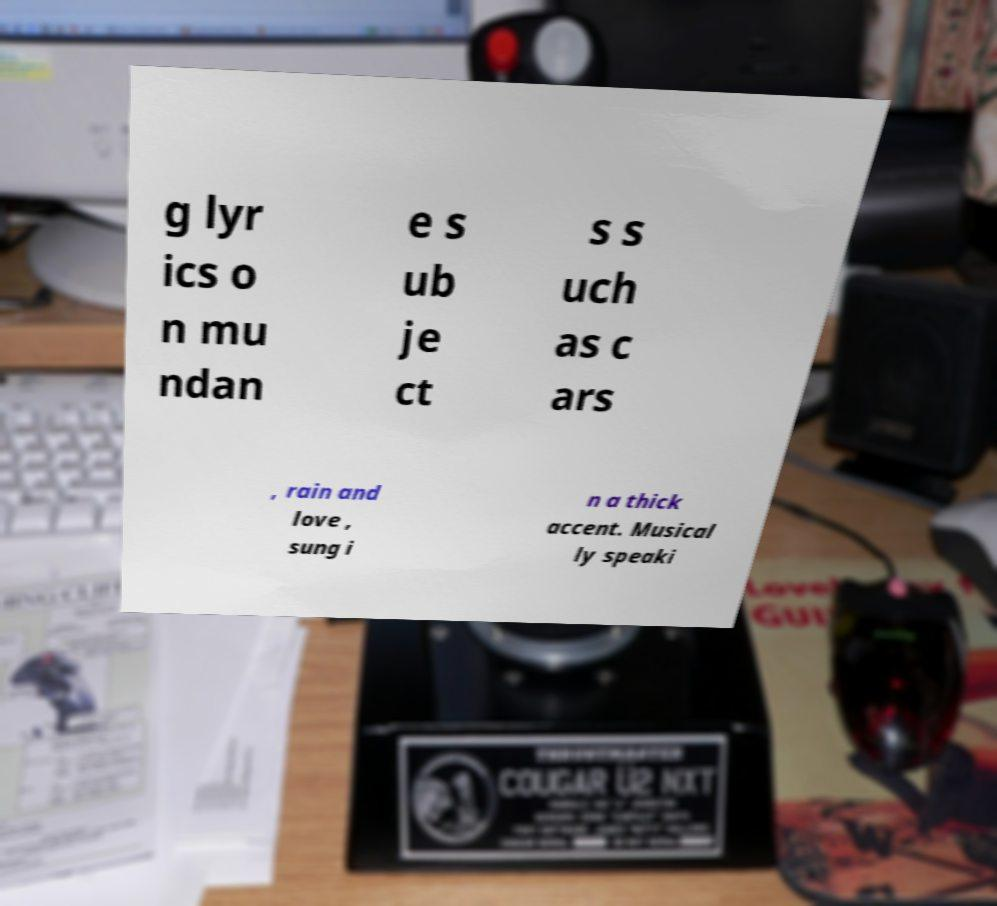For documentation purposes, I need the text within this image transcribed. Could you provide that? g lyr ics o n mu ndan e s ub je ct s s uch as c ars , rain and love , sung i n a thick accent. Musical ly speaki 